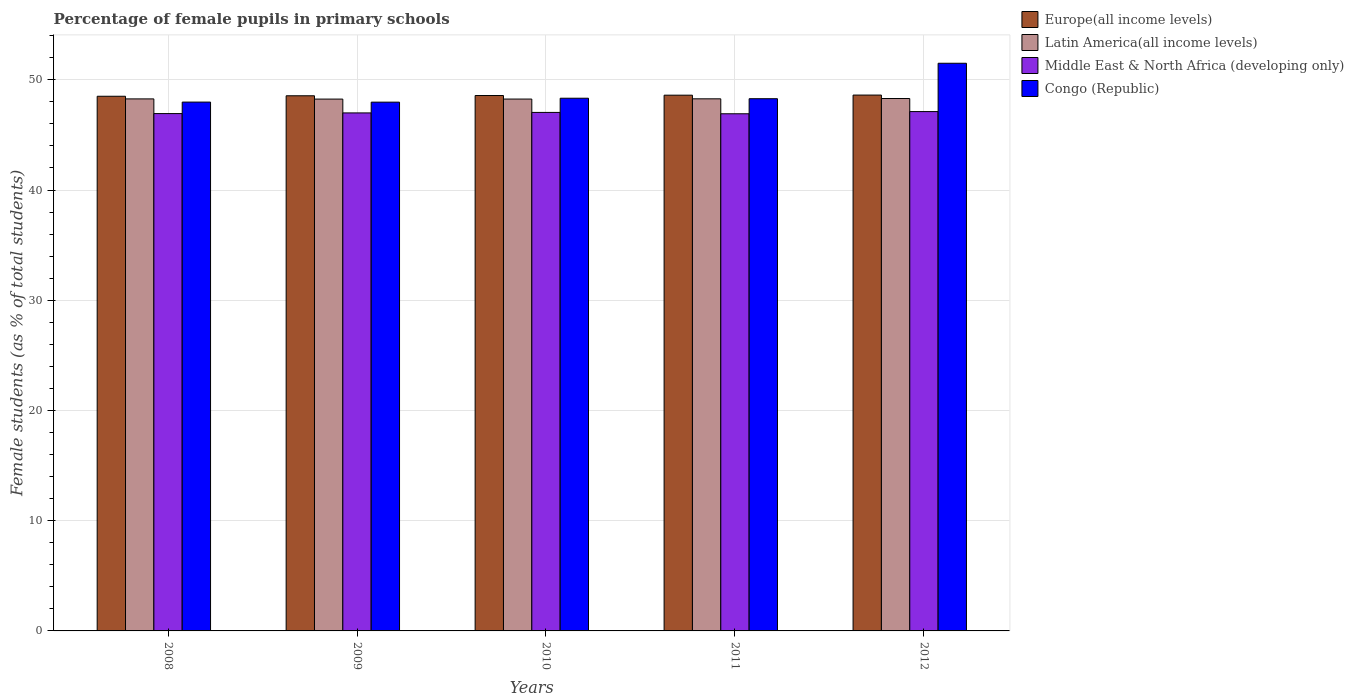How many different coloured bars are there?
Your response must be concise. 4. How many groups of bars are there?
Give a very brief answer. 5. How many bars are there on the 2nd tick from the left?
Ensure brevity in your answer.  4. How many bars are there on the 4th tick from the right?
Give a very brief answer. 4. What is the percentage of female pupils in primary schools in Latin America(all income levels) in 2008?
Your answer should be very brief. 48.27. Across all years, what is the maximum percentage of female pupils in primary schools in Congo (Republic)?
Ensure brevity in your answer.  51.5. Across all years, what is the minimum percentage of female pupils in primary schools in Europe(all income levels)?
Your response must be concise. 48.51. In which year was the percentage of female pupils in primary schools in Latin America(all income levels) minimum?
Ensure brevity in your answer.  2009. What is the total percentage of female pupils in primary schools in Latin America(all income levels) in the graph?
Offer a terse response. 241.35. What is the difference between the percentage of female pupils in primary schools in Latin America(all income levels) in 2008 and that in 2011?
Provide a succinct answer. -0.01. What is the difference between the percentage of female pupils in primary schools in Latin America(all income levels) in 2008 and the percentage of female pupils in primary schools in Europe(all income levels) in 2010?
Provide a short and direct response. -0.31. What is the average percentage of female pupils in primary schools in Latin America(all income levels) per year?
Make the answer very short. 48.27. In the year 2010, what is the difference between the percentage of female pupils in primary schools in Middle East & North Africa (developing only) and percentage of female pupils in primary schools in Congo (Republic)?
Offer a very short reply. -1.29. What is the ratio of the percentage of female pupils in primary schools in Latin America(all income levels) in 2008 to that in 2012?
Provide a short and direct response. 1. Is the difference between the percentage of female pupils in primary schools in Middle East & North Africa (developing only) in 2008 and 2011 greater than the difference between the percentage of female pupils in primary schools in Congo (Republic) in 2008 and 2011?
Offer a very short reply. Yes. What is the difference between the highest and the second highest percentage of female pupils in primary schools in Latin America(all income levels)?
Your response must be concise. 0.03. What is the difference between the highest and the lowest percentage of female pupils in primary schools in Europe(all income levels)?
Your answer should be very brief. 0.11. What does the 2nd bar from the left in 2012 represents?
Keep it short and to the point. Latin America(all income levels). What does the 4th bar from the right in 2008 represents?
Your response must be concise. Europe(all income levels). Is it the case that in every year, the sum of the percentage of female pupils in primary schools in Europe(all income levels) and percentage of female pupils in primary schools in Latin America(all income levels) is greater than the percentage of female pupils in primary schools in Middle East & North Africa (developing only)?
Provide a short and direct response. Yes. How many bars are there?
Your answer should be very brief. 20. Are all the bars in the graph horizontal?
Offer a very short reply. No. How are the legend labels stacked?
Your answer should be very brief. Vertical. What is the title of the graph?
Your answer should be compact. Percentage of female pupils in primary schools. Does "Haiti" appear as one of the legend labels in the graph?
Ensure brevity in your answer.  No. What is the label or title of the Y-axis?
Provide a succinct answer. Female students (as % of total students). What is the Female students (as % of total students) of Europe(all income levels) in 2008?
Provide a short and direct response. 48.51. What is the Female students (as % of total students) of Latin America(all income levels) in 2008?
Offer a terse response. 48.27. What is the Female students (as % of total students) in Middle East & North Africa (developing only) in 2008?
Your answer should be very brief. 46.94. What is the Female students (as % of total students) of Congo (Republic) in 2008?
Your response must be concise. 47.98. What is the Female students (as % of total students) of Europe(all income levels) in 2009?
Your response must be concise. 48.55. What is the Female students (as % of total students) of Latin America(all income levels) in 2009?
Provide a short and direct response. 48.25. What is the Female students (as % of total students) of Middle East & North Africa (developing only) in 2009?
Offer a very short reply. 47. What is the Female students (as % of total students) in Congo (Republic) in 2009?
Ensure brevity in your answer.  47.97. What is the Female students (as % of total students) of Europe(all income levels) in 2010?
Make the answer very short. 48.57. What is the Female students (as % of total students) of Latin America(all income levels) in 2010?
Provide a succinct answer. 48.25. What is the Female students (as % of total students) in Middle East & North Africa (developing only) in 2010?
Your answer should be compact. 47.04. What is the Female students (as % of total students) in Congo (Republic) in 2010?
Provide a short and direct response. 48.33. What is the Female students (as % of total students) in Europe(all income levels) in 2011?
Provide a short and direct response. 48.61. What is the Female students (as % of total students) of Latin America(all income levels) in 2011?
Your answer should be very brief. 48.27. What is the Female students (as % of total students) of Middle East & North Africa (developing only) in 2011?
Ensure brevity in your answer.  46.92. What is the Female students (as % of total students) of Congo (Republic) in 2011?
Keep it short and to the point. 48.29. What is the Female students (as % of total students) of Europe(all income levels) in 2012?
Make the answer very short. 48.62. What is the Female students (as % of total students) in Latin America(all income levels) in 2012?
Offer a terse response. 48.3. What is the Female students (as % of total students) of Middle East & North Africa (developing only) in 2012?
Give a very brief answer. 47.12. What is the Female students (as % of total students) of Congo (Republic) in 2012?
Keep it short and to the point. 51.5. Across all years, what is the maximum Female students (as % of total students) of Europe(all income levels)?
Provide a short and direct response. 48.62. Across all years, what is the maximum Female students (as % of total students) of Latin America(all income levels)?
Provide a short and direct response. 48.3. Across all years, what is the maximum Female students (as % of total students) of Middle East & North Africa (developing only)?
Offer a very short reply. 47.12. Across all years, what is the maximum Female students (as % of total students) in Congo (Republic)?
Give a very brief answer. 51.5. Across all years, what is the minimum Female students (as % of total students) in Europe(all income levels)?
Offer a very short reply. 48.51. Across all years, what is the minimum Female students (as % of total students) in Latin America(all income levels)?
Provide a short and direct response. 48.25. Across all years, what is the minimum Female students (as % of total students) of Middle East & North Africa (developing only)?
Provide a succinct answer. 46.92. Across all years, what is the minimum Female students (as % of total students) in Congo (Republic)?
Offer a terse response. 47.97. What is the total Female students (as % of total students) of Europe(all income levels) in the graph?
Make the answer very short. 242.85. What is the total Female students (as % of total students) of Latin America(all income levels) in the graph?
Ensure brevity in your answer.  241.35. What is the total Female students (as % of total students) of Middle East & North Africa (developing only) in the graph?
Keep it short and to the point. 235.01. What is the total Female students (as % of total students) of Congo (Republic) in the graph?
Keep it short and to the point. 244.07. What is the difference between the Female students (as % of total students) in Europe(all income levels) in 2008 and that in 2009?
Ensure brevity in your answer.  -0.04. What is the difference between the Female students (as % of total students) in Latin America(all income levels) in 2008 and that in 2009?
Ensure brevity in your answer.  0.02. What is the difference between the Female students (as % of total students) of Middle East & North Africa (developing only) in 2008 and that in 2009?
Your answer should be compact. -0.06. What is the difference between the Female students (as % of total students) of Congo (Republic) in 2008 and that in 2009?
Keep it short and to the point. 0.01. What is the difference between the Female students (as % of total students) in Europe(all income levels) in 2008 and that in 2010?
Ensure brevity in your answer.  -0.07. What is the difference between the Female students (as % of total students) of Latin America(all income levels) in 2008 and that in 2010?
Your answer should be very brief. 0.01. What is the difference between the Female students (as % of total students) in Middle East & North Africa (developing only) in 2008 and that in 2010?
Your answer should be compact. -0.11. What is the difference between the Female students (as % of total students) of Congo (Republic) in 2008 and that in 2010?
Your response must be concise. -0.35. What is the difference between the Female students (as % of total students) in Europe(all income levels) in 2008 and that in 2011?
Ensure brevity in your answer.  -0.1. What is the difference between the Female students (as % of total students) of Latin America(all income levels) in 2008 and that in 2011?
Your response must be concise. -0.01. What is the difference between the Female students (as % of total students) in Middle East & North Africa (developing only) in 2008 and that in 2011?
Make the answer very short. 0.02. What is the difference between the Female students (as % of total students) of Congo (Republic) in 2008 and that in 2011?
Offer a very short reply. -0.31. What is the difference between the Female students (as % of total students) of Europe(all income levels) in 2008 and that in 2012?
Ensure brevity in your answer.  -0.11. What is the difference between the Female students (as % of total students) in Latin America(all income levels) in 2008 and that in 2012?
Provide a short and direct response. -0.03. What is the difference between the Female students (as % of total students) of Middle East & North Africa (developing only) in 2008 and that in 2012?
Your answer should be compact. -0.18. What is the difference between the Female students (as % of total students) of Congo (Republic) in 2008 and that in 2012?
Make the answer very short. -3.52. What is the difference between the Female students (as % of total students) of Europe(all income levels) in 2009 and that in 2010?
Keep it short and to the point. -0.02. What is the difference between the Female students (as % of total students) in Latin America(all income levels) in 2009 and that in 2010?
Your answer should be very brief. -0. What is the difference between the Female students (as % of total students) in Middle East & North Africa (developing only) in 2009 and that in 2010?
Your response must be concise. -0.05. What is the difference between the Female students (as % of total students) of Congo (Republic) in 2009 and that in 2010?
Keep it short and to the point. -0.35. What is the difference between the Female students (as % of total students) in Europe(all income levels) in 2009 and that in 2011?
Your response must be concise. -0.05. What is the difference between the Female students (as % of total students) in Latin America(all income levels) in 2009 and that in 2011?
Provide a short and direct response. -0.02. What is the difference between the Female students (as % of total students) in Middle East & North Africa (developing only) in 2009 and that in 2011?
Offer a very short reply. 0.08. What is the difference between the Female students (as % of total students) of Congo (Republic) in 2009 and that in 2011?
Offer a terse response. -0.31. What is the difference between the Female students (as % of total students) in Europe(all income levels) in 2009 and that in 2012?
Your answer should be compact. -0.06. What is the difference between the Female students (as % of total students) in Latin America(all income levels) in 2009 and that in 2012?
Offer a very short reply. -0.05. What is the difference between the Female students (as % of total students) in Middle East & North Africa (developing only) in 2009 and that in 2012?
Make the answer very short. -0.12. What is the difference between the Female students (as % of total students) of Congo (Republic) in 2009 and that in 2012?
Give a very brief answer. -3.53. What is the difference between the Female students (as % of total students) of Europe(all income levels) in 2010 and that in 2011?
Provide a succinct answer. -0.03. What is the difference between the Female students (as % of total students) in Latin America(all income levels) in 2010 and that in 2011?
Your answer should be very brief. -0.02. What is the difference between the Female students (as % of total students) in Middle East & North Africa (developing only) in 2010 and that in 2011?
Give a very brief answer. 0.12. What is the difference between the Female students (as % of total students) in Congo (Republic) in 2010 and that in 2011?
Your response must be concise. 0.04. What is the difference between the Female students (as % of total students) of Europe(all income levels) in 2010 and that in 2012?
Your answer should be very brief. -0.04. What is the difference between the Female students (as % of total students) of Latin America(all income levels) in 2010 and that in 2012?
Keep it short and to the point. -0.05. What is the difference between the Female students (as % of total students) in Middle East & North Africa (developing only) in 2010 and that in 2012?
Your answer should be very brief. -0.07. What is the difference between the Female students (as % of total students) in Congo (Republic) in 2010 and that in 2012?
Your answer should be very brief. -3.17. What is the difference between the Female students (as % of total students) of Europe(all income levels) in 2011 and that in 2012?
Give a very brief answer. -0.01. What is the difference between the Female students (as % of total students) of Latin America(all income levels) in 2011 and that in 2012?
Your response must be concise. -0.03. What is the difference between the Female students (as % of total students) of Middle East & North Africa (developing only) in 2011 and that in 2012?
Offer a terse response. -0.2. What is the difference between the Female students (as % of total students) of Congo (Republic) in 2011 and that in 2012?
Ensure brevity in your answer.  -3.22. What is the difference between the Female students (as % of total students) of Europe(all income levels) in 2008 and the Female students (as % of total students) of Latin America(all income levels) in 2009?
Offer a very short reply. 0.26. What is the difference between the Female students (as % of total students) of Europe(all income levels) in 2008 and the Female students (as % of total students) of Middle East & North Africa (developing only) in 2009?
Your response must be concise. 1.51. What is the difference between the Female students (as % of total students) in Europe(all income levels) in 2008 and the Female students (as % of total students) in Congo (Republic) in 2009?
Make the answer very short. 0.53. What is the difference between the Female students (as % of total students) of Latin America(all income levels) in 2008 and the Female students (as % of total students) of Middle East & North Africa (developing only) in 2009?
Your response must be concise. 1.27. What is the difference between the Female students (as % of total students) of Latin America(all income levels) in 2008 and the Female students (as % of total students) of Congo (Republic) in 2009?
Offer a very short reply. 0.29. What is the difference between the Female students (as % of total students) in Middle East & North Africa (developing only) in 2008 and the Female students (as % of total students) in Congo (Republic) in 2009?
Your answer should be compact. -1.04. What is the difference between the Female students (as % of total students) of Europe(all income levels) in 2008 and the Female students (as % of total students) of Latin America(all income levels) in 2010?
Make the answer very short. 0.25. What is the difference between the Female students (as % of total students) in Europe(all income levels) in 2008 and the Female students (as % of total students) in Middle East & North Africa (developing only) in 2010?
Keep it short and to the point. 1.46. What is the difference between the Female students (as % of total students) of Europe(all income levels) in 2008 and the Female students (as % of total students) of Congo (Republic) in 2010?
Keep it short and to the point. 0.18. What is the difference between the Female students (as % of total students) in Latin America(all income levels) in 2008 and the Female students (as % of total students) in Middle East & North Africa (developing only) in 2010?
Your response must be concise. 1.23. What is the difference between the Female students (as % of total students) in Latin America(all income levels) in 2008 and the Female students (as % of total students) in Congo (Republic) in 2010?
Make the answer very short. -0.06. What is the difference between the Female students (as % of total students) in Middle East & North Africa (developing only) in 2008 and the Female students (as % of total students) in Congo (Republic) in 2010?
Offer a very short reply. -1.39. What is the difference between the Female students (as % of total students) of Europe(all income levels) in 2008 and the Female students (as % of total students) of Latin America(all income levels) in 2011?
Make the answer very short. 0.23. What is the difference between the Female students (as % of total students) in Europe(all income levels) in 2008 and the Female students (as % of total students) in Middle East & North Africa (developing only) in 2011?
Offer a very short reply. 1.59. What is the difference between the Female students (as % of total students) of Europe(all income levels) in 2008 and the Female students (as % of total students) of Congo (Republic) in 2011?
Your answer should be very brief. 0.22. What is the difference between the Female students (as % of total students) of Latin America(all income levels) in 2008 and the Female students (as % of total students) of Middle East & North Africa (developing only) in 2011?
Ensure brevity in your answer.  1.35. What is the difference between the Female students (as % of total students) in Latin America(all income levels) in 2008 and the Female students (as % of total students) in Congo (Republic) in 2011?
Your response must be concise. -0.02. What is the difference between the Female students (as % of total students) of Middle East & North Africa (developing only) in 2008 and the Female students (as % of total students) of Congo (Republic) in 2011?
Offer a very short reply. -1.35. What is the difference between the Female students (as % of total students) of Europe(all income levels) in 2008 and the Female students (as % of total students) of Latin America(all income levels) in 2012?
Provide a short and direct response. 0.2. What is the difference between the Female students (as % of total students) in Europe(all income levels) in 2008 and the Female students (as % of total students) in Middle East & North Africa (developing only) in 2012?
Give a very brief answer. 1.39. What is the difference between the Female students (as % of total students) of Europe(all income levels) in 2008 and the Female students (as % of total students) of Congo (Republic) in 2012?
Provide a short and direct response. -2.99. What is the difference between the Female students (as % of total students) in Latin America(all income levels) in 2008 and the Female students (as % of total students) in Middle East & North Africa (developing only) in 2012?
Keep it short and to the point. 1.15. What is the difference between the Female students (as % of total students) in Latin America(all income levels) in 2008 and the Female students (as % of total students) in Congo (Republic) in 2012?
Your response must be concise. -3.23. What is the difference between the Female students (as % of total students) of Middle East & North Africa (developing only) in 2008 and the Female students (as % of total students) of Congo (Republic) in 2012?
Your answer should be compact. -4.57. What is the difference between the Female students (as % of total students) of Europe(all income levels) in 2009 and the Female students (as % of total students) of Latin America(all income levels) in 2010?
Provide a short and direct response. 0.3. What is the difference between the Female students (as % of total students) in Europe(all income levels) in 2009 and the Female students (as % of total students) in Middle East & North Africa (developing only) in 2010?
Make the answer very short. 1.51. What is the difference between the Female students (as % of total students) of Europe(all income levels) in 2009 and the Female students (as % of total students) of Congo (Republic) in 2010?
Provide a succinct answer. 0.22. What is the difference between the Female students (as % of total students) of Latin America(all income levels) in 2009 and the Female students (as % of total students) of Middle East & North Africa (developing only) in 2010?
Your answer should be compact. 1.21. What is the difference between the Female students (as % of total students) of Latin America(all income levels) in 2009 and the Female students (as % of total students) of Congo (Republic) in 2010?
Give a very brief answer. -0.08. What is the difference between the Female students (as % of total students) in Middle East & North Africa (developing only) in 2009 and the Female students (as % of total students) in Congo (Republic) in 2010?
Ensure brevity in your answer.  -1.33. What is the difference between the Female students (as % of total students) of Europe(all income levels) in 2009 and the Female students (as % of total students) of Latin America(all income levels) in 2011?
Provide a short and direct response. 0.28. What is the difference between the Female students (as % of total students) in Europe(all income levels) in 2009 and the Female students (as % of total students) in Middle East & North Africa (developing only) in 2011?
Your answer should be very brief. 1.63. What is the difference between the Female students (as % of total students) of Europe(all income levels) in 2009 and the Female students (as % of total students) of Congo (Republic) in 2011?
Your answer should be very brief. 0.27. What is the difference between the Female students (as % of total students) of Latin America(all income levels) in 2009 and the Female students (as % of total students) of Middle East & North Africa (developing only) in 2011?
Your response must be concise. 1.33. What is the difference between the Female students (as % of total students) in Latin America(all income levels) in 2009 and the Female students (as % of total students) in Congo (Republic) in 2011?
Provide a short and direct response. -0.03. What is the difference between the Female students (as % of total students) in Middle East & North Africa (developing only) in 2009 and the Female students (as % of total students) in Congo (Republic) in 2011?
Your answer should be compact. -1.29. What is the difference between the Female students (as % of total students) in Europe(all income levels) in 2009 and the Female students (as % of total students) in Latin America(all income levels) in 2012?
Your answer should be very brief. 0.25. What is the difference between the Female students (as % of total students) of Europe(all income levels) in 2009 and the Female students (as % of total students) of Middle East & North Africa (developing only) in 2012?
Your answer should be very brief. 1.44. What is the difference between the Female students (as % of total students) in Europe(all income levels) in 2009 and the Female students (as % of total students) in Congo (Republic) in 2012?
Make the answer very short. -2.95. What is the difference between the Female students (as % of total students) of Latin America(all income levels) in 2009 and the Female students (as % of total students) of Middle East & North Africa (developing only) in 2012?
Make the answer very short. 1.13. What is the difference between the Female students (as % of total students) in Latin America(all income levels) in 2009 and the Female students (as % of total students) in Congo (Republic) in 2012?
Ensure brevity in your answer.  -3.25. What is the difference between the Female students (as % of total students) of Middle East & North Africa (developing only) in 2009 and the Female students (as % of total students) of Congo (Republic) in 2012?
Keep it short and to the point. -4.51. What is the difference between the Female students (as % of total students) of Europe(all income levels) in 2010 and the Female students (as % of total students) of Latin America(all income levels) in 2011?
Provide a short and direct response. 0.3. What is the difference between the Female students (as % of total students) in Europe(all income levels) in 2010 and the Female students (as % of total students) in Middle East & North Africa (developing only) in 2011?
Your response must be concise. 1.66. What is the difference between the Female students (as % of total students) of Europe(all income levels) in 2010 and the Female students (as % of total students) of Congo (Republic) in 2011?
Provide a succinct answer. 0.29. What is the difference between the Female students (as % of total students) in Latin America(all income levels) in 2010 and the Female students (as % of total students) in Middle East & North Africa (developing only) in 2011?
Provide a short and direct response. 1.33. What is the difference between the Female students (as % of total students) of Latin America(all income levels) in 2010 and the Female students (as % of total students) of Congo (Republic) in 2011?
Your response must be concise. -0.03. What is the difference between the Female students (as % of total students) in Middle East & North Africa (developing only) in 2010 and the Female students (as % of total students) in Congo (Republic) in 2011?
Keep it short and to the point. -1.24. What is the difference between the Female students (as % of total students) of Europe(all income levels) in 2010 and the Female students (as % of total students) of Latin America(all income levels) in 2012?
Keep it short and to the point. 0.27. What is the difference between the Female students (as % of total students) in Europe(all income levels) in 2010 and the Female students (as % of total students) in Middle East & North Africa (developing only) in 2012?
Offer a terse response. 1.46. What is the difference between the Female students (as % of total students) of Europe(all income levels) in 2010 and the Female students (as % of total students) of Congo (Republic) in 2012?
Ensure brevity in your answer.  -2.93. What is the difference between the Female students (as % of total students) of Latin America(all income levels) in 2010 and the Female students (as % of total students) of Middle East & North Africa (developing only) in 2012?
Make the answer very short. 1.14. What is the difference between the Female students (as % of total students) in Latin America(all income levels) in 2010 and the Female students (as % of total students) in Congo (Republic) in 2012?
Your answer should be very brief. -3.25. What is the difference between the Female students (as % of total students) of Middle East & North Africa (developing only) in 2010 and the Female students (as % of total students) of Congo (Republic) in 2012?
Keep it short and to the point. -4.46. What is the difference between the Female students (as % of total students) in Europe(all income levels) in 2011 and the Female students (as % of total students) in Latin America(all income levels) in 2012?
Offer a terse response. 0.3. What is the difference between the Female students (as % of total students) in Europe(all income levels) in 2011 and the Female students (as % of total students) in Middle East & North Africa (developing only) in 2012?
Your answer should be compact. 1.49. What is the difference between the Female students (as % of total students) in Europe(all income levels) in 2011 and the Female students (as % of total students) in Congo (Republic) in 2012?
Your answer should be very brief. -2.9. What is the difference between the Female students (as % of total students) of Latin America(all income levels) in 2011 and the Female students (as % of total students) of Middle East & North Africa (developing only) in 2012?
Your response must be concise. 1.16. What is the difference between the Female students (as % of total students) of Latin America(all income levels) in 2011 and the Female students (as % of total students) of Congo (Republic) in 2012?
Your answer should be very brief. -3.23. What is the difference between the Female students (as % of total students) of Middle East & North Africa (developing only) in 2011 and the Female students (as % of total students) of Congo (Republic) in 2012?
Provide a short and direct response. -4.58. What is the average Female students (as % of total students) in Europe(all income levels) per year?
Provide a short and direct response. 48.57. What is the average Female students (as % of total students) of Latin America(all income levels) per year?
Make the answer very short. 48.27. What is the average Female students (as % of total students) in Middle East & North Africa (developing only) per year?
Provide a short and direct response. 47. What is the average Female students (as % of total students) of Congo (Republic) per year?
Ensure brevity in your answer.  48.81. In the year 2008, what is the difference between the Female students (as % of total students) in Europe(all income levels) and Female students (as % of total students) in Latin America(all income levels)?
Provide a short and direct response. 0.24. In the year 2008, what is the difference between the Female students (as % of total students) in Europe(all income levels) and Female students (as % of total students) in Middle East & North Africa (developing only)?
Make the answer very short. 1.57. In the year 2008, what is the difference between the Female students (as % of total students) of Europe(all income levels) and Female students (as % of total students) of Congo (Republic)?
Your answer should be compact. 0.53. In the year 2008, what is the difference between the Female students (as % of total students) in Latin America(all income levels) and Female students (as % of total students) in Middle East & North Africa (developing only)?
Your response must be concise. 1.33. In the year 2008, what is the difference between the Female students (as % of total students) of Latin America(all income levels) and Female students (as % of total students) of Congo (Republic)?
Your response must be concise. 0.29. In the year 2008, what is the difference between the Female students (as % of total students) of Middle East & North Africa (developing only) and Female students (as % of total students) of Congo (Republic)?
Provide a succinct answer. -1.04. In the year 2009, what is the difference between the Female students (as % of total students) in Europe(all income levels) and Female students (as % of total students) in Latin America(all income levels)?
Your answer should be very brief. 0.3. In the year 2009, what is the difference between the Female students (as % of total students) in Europe(all income levels) and Female students (as % of total students) in Middle East & North Africa (developing only)?
Your response must be concise. 1.56. In the year 2009, what is the difference between the Female students (as % of total students) of Europe(all income levels) and Female students (as % of total students) of Congo (Republic)?
Make the answer very short. 0.58. In the year 2009, what is the difference between the Female students (as % of total students) in Latin America(all income levels) and Female students (as % of total students) in Middle East & North Africa (developing only)?
Make the answer very short. 1.25. In the year 2009, what is the difference between the Female students (as % of total students) in Latin America(all income levels) and Female students (as % of total students) in Congo (Republic)?
Make the answer very short. 0.28. In the year 2009, what is the difference between the Female students (as % of total students) of Middle East & North Africa (developing only) and Female students (as % of total students) of Congo (Republic)?
Provide a short and direct response. -0.98. In the year 2010, what is the difference between the Female students (as % of total students) of Europe(all income levels) and Female students (as % of total students) of Latin America(all income levels)?
Your answer should be compact. 0.32. In the year 2010, what is the difference between the Female students (as % of total students) in Europe(all income levels) and Female students (as % of total students) in Middle East & North Africa (developing only)?
Make the answer very short. 1.53. In the year 2010, what is the difference between the Female students (as % of total students) of Europe(all income levels) and Female students (as % of total students) of Congo (Republic)?
Provide a short and direct response. 0.25. In the year 2010, what is the difference between the Female students (as % of total students) of Latin America(all income levels) and Female students (as % of total students) of Middle East & North Africa (developing only)?
Offer a terse response. 1.21. In the year 2010, what is the difference between the Female students (as % of total students) of Latin America(all income levels) and Female students (as % of total students) of Congo (Republic)?
Provide a short and direct response. -0.07. In the year 2010, what is the difference between the Female students (as % of total students) of Middle East & North Africa (developing only) and Female students (as % of total students) of Congo (Republic)?
Offer a terse response. -1.29. In the year 2011, what is the difference between the Female students (as % of total students) of Europe(all income levels) and Female students (as % of total students) of Latin America(all income levels)?
Your answer should be very brief. 0.33. In the year 2011, what is the difference between the Female students (as % of total students) in Europe(all income levels) and Female students (as % of total students) in Middle East & North Africa (developing only)?
Keep it short and to the point. 1.69. In the year 2011, what is the difference between the Female students (as % of total students) in Europe(all income levels) and Female students (as % of total students) in Congo (Republic)?
Make the answer very short. 0.32. In the year 2011, what is the difference between the Female students (as % of total students) of Latin America(all income levels) and Female students (as % of total students) of Middle East & North Africa (developing only)?
Give a very brief answer. 1.36. In the year 2011, what is the difference between the Female students (as % of total students) in Latin America(all income levels) and Female students (as % of total students) in Congo (Republic)?
Ensure brevity in your answer.  -0.01. In the year 2011, what is the difference between the Female students (as % of total students) in Middle East & North Africa (developing only) and Female students (as % of total students) in Congo (Republic)?
Ensure brevity in your answer.  -1.37. In the year 2012, what is the difference between the Female students (as % of total students) of Europe(all income levels) and Female students (as % of total students) of Latin America(all income levels)?
Give a very brief answer. 0.31. In the year 2012, what is the difference between the Female students (as % of total students) in Europe(all income levels) and Female students (as % of total students) in Middle East & North Africa (developing only)?
Provide a succinct answer. 1.5. In the year 2012, what is the difference between the Female students (as % of total students) in Europe(all income levels) and Female students (as % of total students) in Congo (Republic)?
Your answer should be compact. -2.89. In the year 2012, what is the difference between the Female students (as % of total students) in Latin America(all income levels) and Female students (as % of total students) in Middle East & North Africa (developing only)?
Give a very brief answer. 1.19. In the year 2012, what is the difference between the Female students (as % of total students) in Latin America(all income levels) and Female students (as % of total students) in Congo (Republic)?
Your response must be concise. -3.2. In the year 2012, what is the difference between the Female students (as % of total students) in Middle East & North Africa (developing only) and Female students (as % of total students) in Congo (Republic)?
Ensure brevity in your answer.  -4.38. What is the ratio of the Female students (as % of total students) in Latin America(all income levels) in 2008 to that in 2009?
Make the answer very short. 1. What is the ratio of the Female students (as % of total students) in Congo (Republic) in 2008 to that in 2009?
Offer a terse response. 1. What is the ratio of the Female students (as % of total students) in Latin America(all income levels) in 2008 to that in 2010?
Ensure brevity in your answer.  1. What is the ratio of the Female students (as % of total students) of Congo (Republic) in 2008 to that in 2010?
Keep it short and to the point. 0.99. What is the ratio of the Female students (as % of total students) in Europe(all income levels) in 2008 to that in 2011?
Provide a short and direct response. 1. What is the ratio of the Female students (as % of total students) of Latin America(all income levels) in 2008 to that in 2011?
Give a very brief answer. 1. What is the ratio of the Female students (as % of total students) in Congo (Republic) in 2008 to that in 2011?
Offer a terse response. 0.99. What is the ratio of the Female students (as % of total students) in Latin America(all income levels) in 2008 to that in 2012?
Your answer should be compact. 1. What is the ratio of the Female students (as % of total students) in Congo (Republic) in 2008 to that in 2012?
Your answer should be compact. 0.93. What is the ratio of the Female students (as % of total students) in Europe(all income levels) in 2009 to that in 2010?
Keep it short and to the point. 1. What is the ratio of the Female students (as % of total students) of Middle East & North Africa (developing only) in 2009 to that in 2010?
Your answer should be very brief. 1. What is the ratio of the Female students (as % of total students) of Latin America(all income levels) in 2009 to that in 2011?
Provide a succinct answer. 1. What is the ratio of the Female students (as % of total students) in Middle East & North Africa (developing only) in 2009 to that in 2011?
Provide a succinct answer. 1. What is the ratio of the Female students (as % of total students) in Congo (Republic) in 2009 to that in 2011?
Provide a succinct answer. 0.99. What is the ratio of the Female students (as % of total students) in Europe(all income levels) in 2009 to that in 2012?
Give a very brief answer. 1. What is the ratio of the Female students (as % of total students) of Congo (Republic) in 2009 to that in 2012?
Make the answer very short. 0.93. What is the ratio of the Female students (as % of total students) of Europe(all income levels) in 2010 to that in 2011?
Make the answer very short. 1. What is the ratio of the Female students (as % of total students) in Middle East & North Africa (developing only) in 2010 to that in 2011?
Ensure brevity in your answer.  1. What is the ratio of the Female students (as % of total students) in Middle East & North Africa (developing only) in 2010 to that in 2012?
Offer a very short reply. 1. What is the ratio of the Female students (as % of total students) in Congo (Republic) in 2010 to that in 2012?
Keep it short and to the point. 0.94. What is the ratio of the Female students (as % of total students) in Congo (Republic) in 2011 to that in 2012?
Keep it short and to the point. 0.94. What is the difference between the highest and the second highest Female students (as % of total students) in Europe(all income levels)?
Keep it short and to the point. 0.01. What is the difference between the highest and the second highest Female students (as % of total students) in Latin America(all income levels)?
Offer a terse response. 0.03. What is the difference between the highest and the second highest Female students (as % of total students) of Middle East & North Africa (developing only)?
Ensure brevity in your answer.  0.07. What is the difference between the highest and the second highest Female students (as % of total students) in Congo (Republic)?
Ensure brevity in your answer.  3.17. What is the difference between the highest and the lowest Female students (as % of total students) of Europe(all income levels)?
Offer a very short reply. 0.11. What is the difference between the highest and the lowest Female students (as % of total students) of Latin America(all income levels)?
Offer a terse response. 0.05. What is the difference between the highest and the lowest Female students (as % of total students) in Middle East & North Africa (developing only)?
Offer a very short reply. 0.2. What is the difference between the highest and the lowest Female students (as % of total students) in Congo (Republic)?
Make the answer very short. 3.53. 